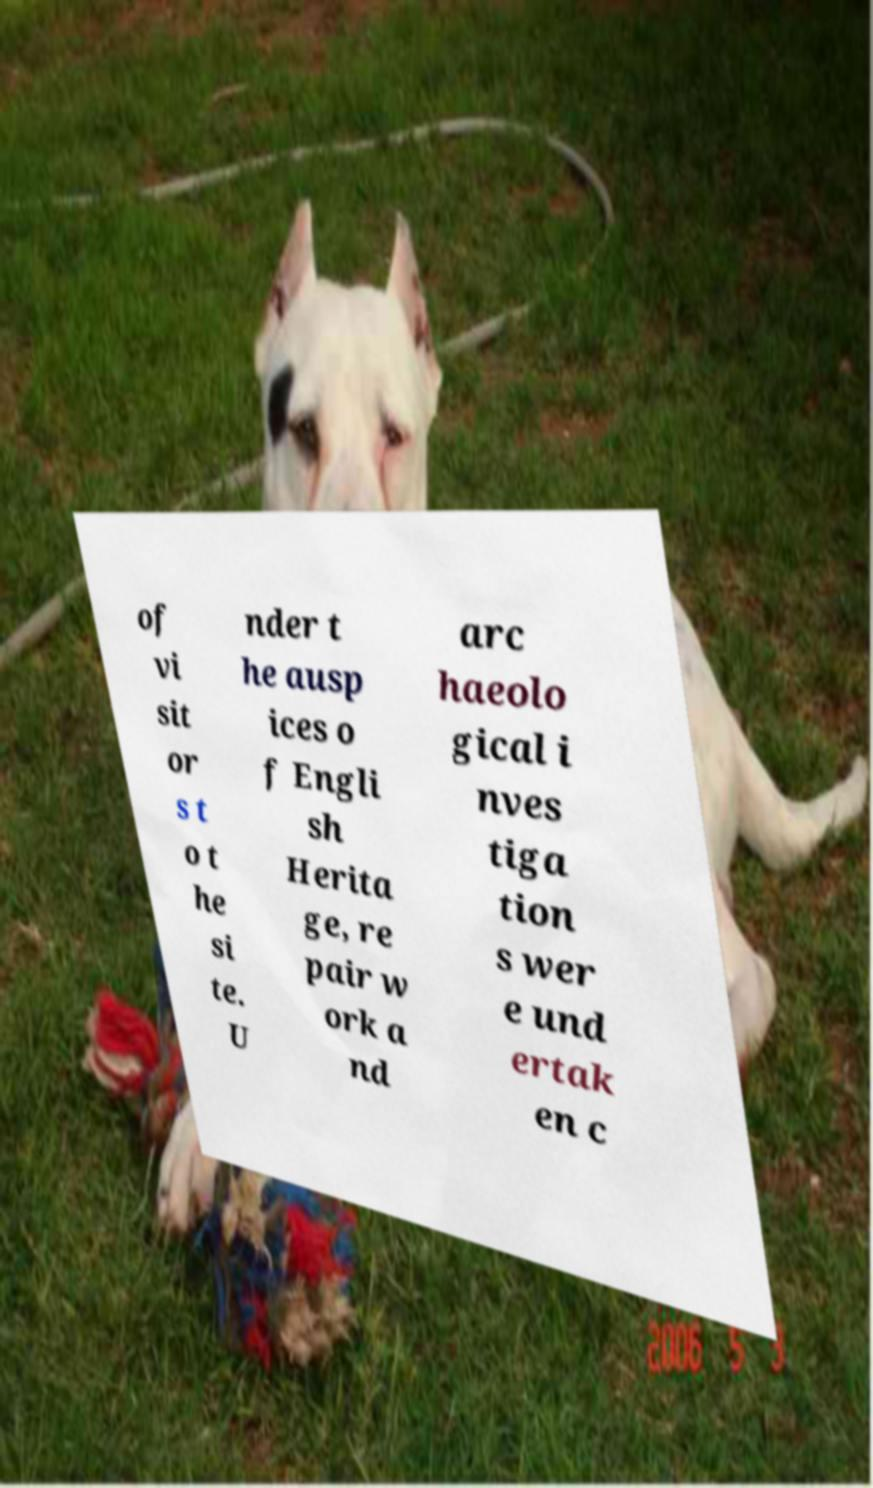There's text embedded in this image that I need extracted. Can you transcribe it verbatim? of vi sit or s t o t he si te. U nder t he ausp ices o f Engli sh Herita ge, re pair w ork a nd arc haeolo gical i nves tiga tion s wer e und ertak en c 